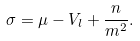<formula> <loc_0><loc_0><loc_500><loc_500>\sigma = \mu - V _ { l } + \frac { n } { m ^ { 2 } } .</formula> 